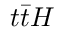Convert formula to latex. <formula><loc_0><loc_0><loc_500><loc_500>t \bar { t } H</formula> 